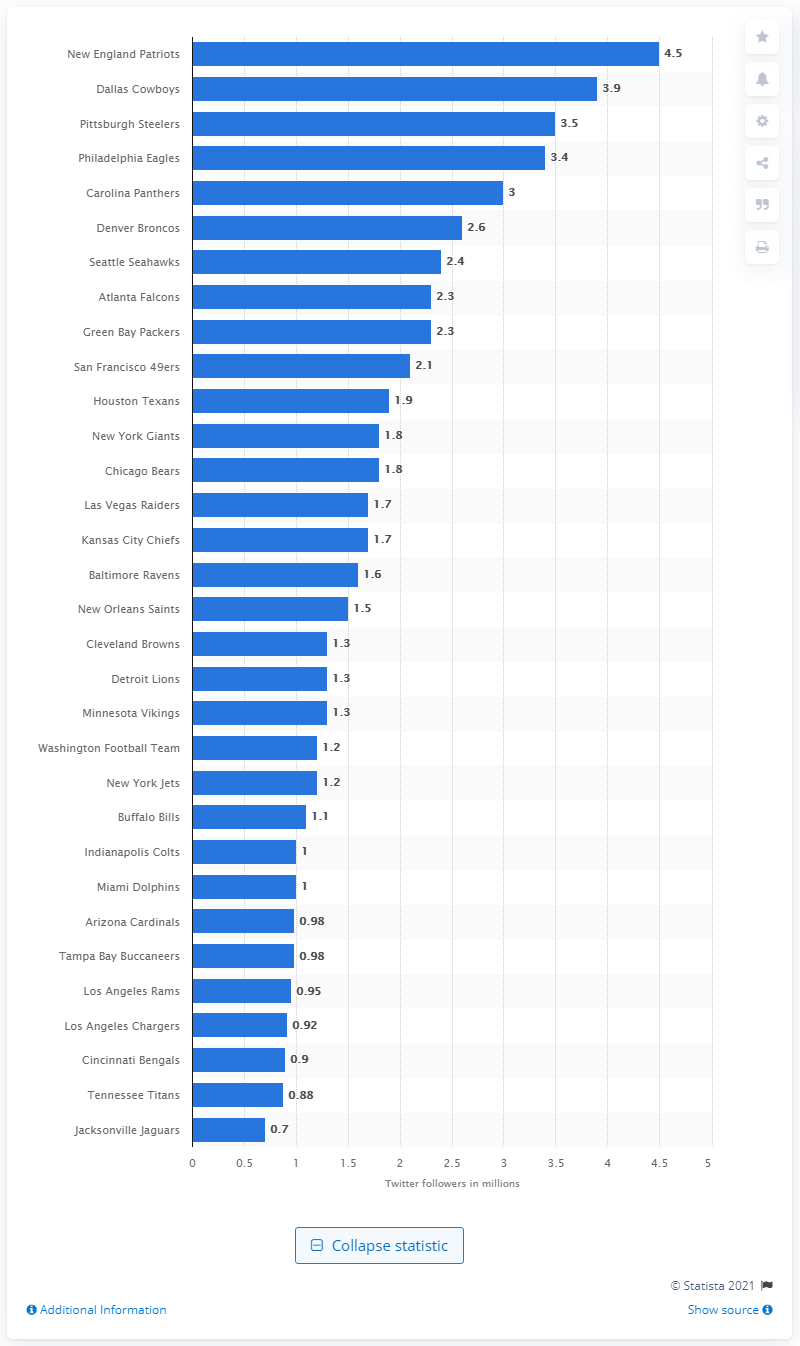Give some essential details in this illustration. The New England Patriots have 4.5 million followers on Twitter. 